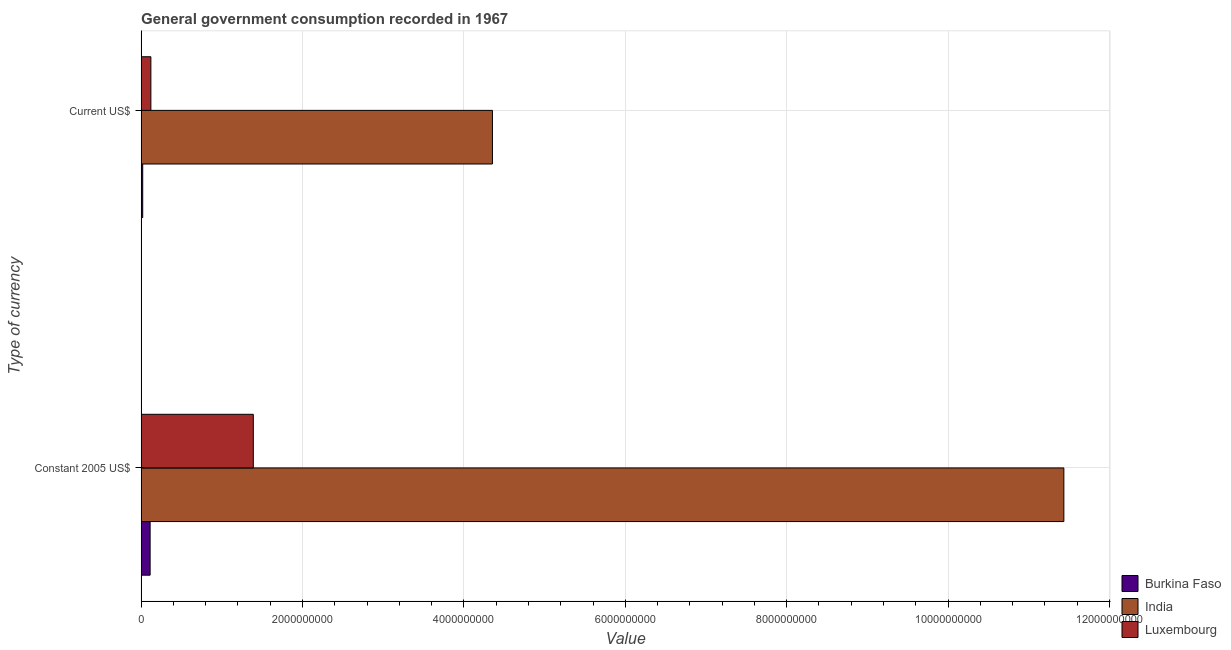How many different coloured bars are there?
Ensure brevity in your answer.  3. Are the number of bars on each tick of the Y-axis equal?
Offer a very short reply. Yes. How many bars are there on the 1st tick from the top?
Give a very brief answer. 3. What is the label of the 1st group of bars from the top?
Keep it short and to the point. Current US$. What is the value consumed in current us$ in India?
Ensure brevity in your answer.  4.35e+09. Across all countries, what is the maximum value consumed in current us$?
Offer a very short reply. 4.35e+09. Across all countries, what is the minimum value consumed in constant 2005 us$?
Make the answer very short. 1.11e+08. In which country was the value consumed in constant 2005 us$ minimum?
Give a very brief answer. Burkina Faso. What is the total value consumed in constant 2005 us$ in the graph?
Your answer should be compact. 1.29e+1. What is the difference between the value consumed in constant 2005 us$ in India and that in Burkina Faso?
Provide a short and direct response. 1.13e+1. What is the difference between the value consumed in current us$ in India and the value consumed in constant 2005 us$ in Burkina Faso?
Your response must be concise. 4.24e+09. What is the average value consumed in current us$ per country?
Your answer should be compact. 1.50e+09. What is the difference between the value consumed in constant 2005 us$ and value consumed in current us$ in Burkina Faso?
Offer a very short reply. 9.19e+07. In how many countries, is the value consumed in constant 2005 us$ greater than 4800000000 ?
Your answer should be compact. 1. What is the ratio of the value consumed in constant 2005 us$ in Luxembourg to that in Burkina Faso?
Provide a short and direct response. 12.48. Is the value consumed in current us$ in Luxembourg less than that in Burkina Faso?
Your response must be concise. No. What does the 1st bar from the top in Current US$ represents?
Give a very brief answer. Luxembourg. What does the 3rd bar from the bottom in Constant 2005 US$ represents?
Your answer should be very brief. Luxembourg. How many bars are there?
Offer a very short reply. 6. How many countries are there in the graph?
Offer a terse response. 3. What is the difference between two consecutive major ticks on the X-axis?
Make the answer very short. 2.00e+09. Are the values on the major ticks of X-axis written in scientific E-notation?
Give a very brief answer. No. Does the graph contain grids?
Offer a terse response. Yes. How many legend labels are there?
Make the answer very short. 3. How are the legend labels stacked?
Your answer should be very brief. Vertical. What is the title of the graph?
Your response must be concise. General government consumption recorded in 1967. Does "San Marino" appear as one of the legend labels in the graph?
Provide a succinct answer. No. What is the label or title of the X-axis?
Ensure brevity in your answer.  Value. What is the label or title of the Y-axis?
Provide a short and direct response. Type of currency. What is the Value in Burkina Faso in Constant 2005 US$?
Make the answer very short. 1.11e+08. What is the Value in India in Constant 2005 US$?
Offer a very short reply. 1.14e+1. What is the Value in Luxembourg in Constant 2005 US$?
Make the answer very short. 1.39e+09. What is the Value in Burkina Faso in Current US$?
Ensure brevity in your answer.  1.95e+07. What is the Value in India in Current US$?
Offer a very short reply. 4.35e+09. What is the Value in Luxembourg in Current US$?
Offer a very short reply. 1.20e+08. Across all Type of currency, what is the maximum Value in Burkina Faso?
Offer a terse response. 1.11e+08. Across all Type of currency, what is the maximum Value in India?
Give a very brief answer. 1.14e+1. Across all Type of currency, what is the maximum Value of Luxembourg?
Your response must be concise. 1.39e+09. Across all Type of currency, what is the minimum Value in Burkina Faso?
Keep it short and to the point. 1.95e+07. Across all Type of currency, what is the minimum Value of India?
Give a very brief answer. 4.35e+09. Across all Type of currency, what is the minimum Value in Luxembourg?
Ensure brevity in your answer.  1.20e+08. What is the total Value of Burkina Faso in the graph?
Provide a succinct answer. 1.31e+08. What is the total Value in India in the graph?
Keep it short and to the point. 1.58e+1. What is the total Value in Luxembourg in the graph?
Give a very brief answer. 1.51e+09. What is the difference between the Value of Burkina Faso in Constant 2005 US$ and that in Current US$?
Ensure brevity in your answer.  9.19e+07. What is the difference between the Value of India in Constant 2005 US$ and that in Current US$?
Your response must be concise. 7.08e+09. What is the difference between the Value in Luxembourg in Constant 2005 US$ and that in Current US$?
Give a very brief answer. 1.27e+09. What is the difference between the Value of Burkina Faso in Constant 2005 US$ and the Value of India in Current US$?
Provide a succinct answer. -4.24e+09. What is the difference between the Value of Burkina Faso in Constant 2005 US$ and the Value of Luxembourg in Current US$?
Offer a very short reply. -9.16e+06. What is the difference between the Value of India in Constant 2005 US$ and the Value of Luxembourg in Current US$?
Ensure brevity in your answer.  1.13e+1. What is the average Value of Burkina Faso per Type of currency?
Your response must be concise. 6.54e+07. What is the average Value of India per Type of currency?
Your response must be concise. 7.89e+09. What is the average Value of Luxembourg per Type of currency?
Make the answer very short. 7.55e+08. What is the difference between the Value in Burkina Faso and Value in India in Constant 2005 US$?
Ensure brevity in your answer.  -1.13e+1. What is the difference between the Value of Burkina Faso and Value of Luxembourg in Constant 2005 US$?
Your answer should be very brief. -1.28e+09. What is the difference between the Value in India and Value in Luxembourg in Constant 2005 US$?
Make the answer very short. 1.00e+1. What is the difference between the Value of Burkina Faso and Value of India in Current US$?
Provide a short and direct response. -4.33e+09. What is the difference between the Value in Burkina Faso and Value in Luxembourg in Current US$?
Provide a short and direct response. -1.01e+08. What is the difference between the Value in India and Value in Luxembourg in Current US$?
Your answer should be compact. 4.23e+09. What is the ratio of the Value in Burkina Faso in Constant 2005 US$ to that in Current US$?
Provide a succinct answer. 5.72. What is the ratio of the Value of India in Constant 2005 US$ to that in Current US$?
Keep it short and to the point. 2.63. What is the ratio of the Value of Luxembourg in Constant 2005 US$ to that in Current US$?
Offer a terse response. 11.54. What is the difference between the highest and the second highest Value in Burkina Faso?
Offer a terse response. 9.19e+07. What is the difference between the highest and the second highest Value of India?
Make the answer very short. 7.08e+09. What is the difference between the highest and the second highest Value of Luxembourg?
Make the answer very short. 1.27e+09. What is the difference between the highest and the lowest Value of Burkina Faso?
Your response must be concise. 9.19e+07. What is the difference between the highest and the lowest Value in India?
Your answer should be compact. 7.08e+09. What is the difference between the highest and the lowest Value of Luxembourg?
Your response must be concise. 1.27e+09. 